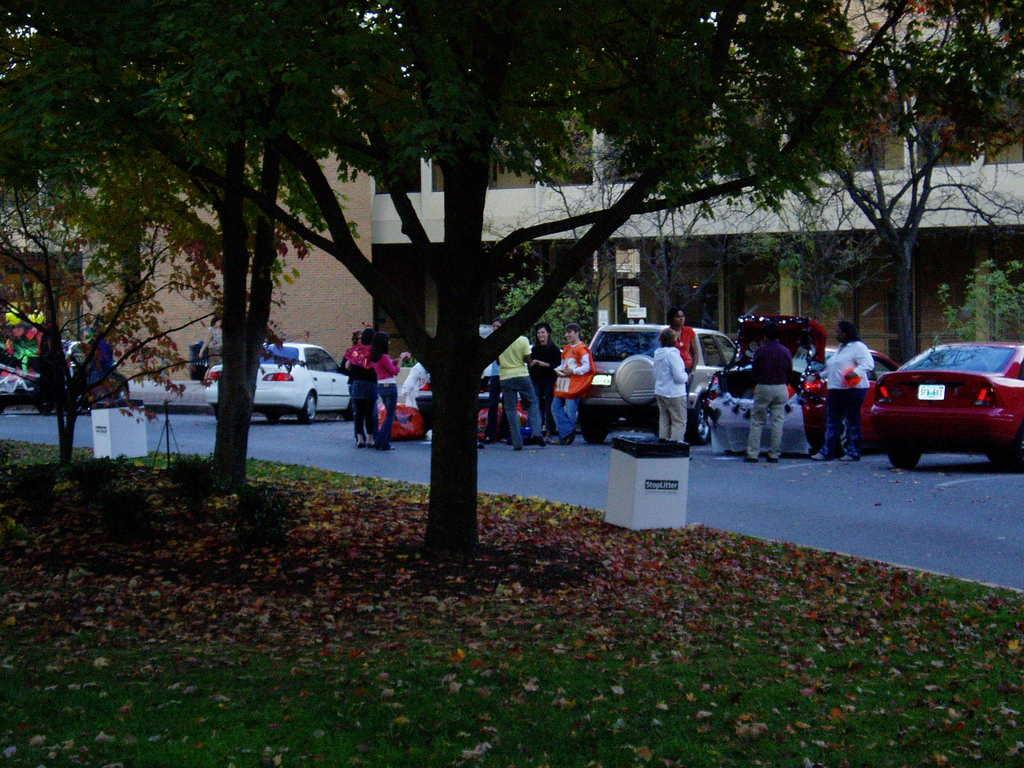What are the people in the image doing? The people in the image are standing beside cars. Where are the people located in relation to the building? The people are in front of a building. What type of vegetation can be seen in the image? There are trees visible in the image. Where are the trees located? The trees are located in a garden. What channel is the people watching on the TV in the image? There is no TV present in the image, so it is not possible to determine what channel they might be watching. 